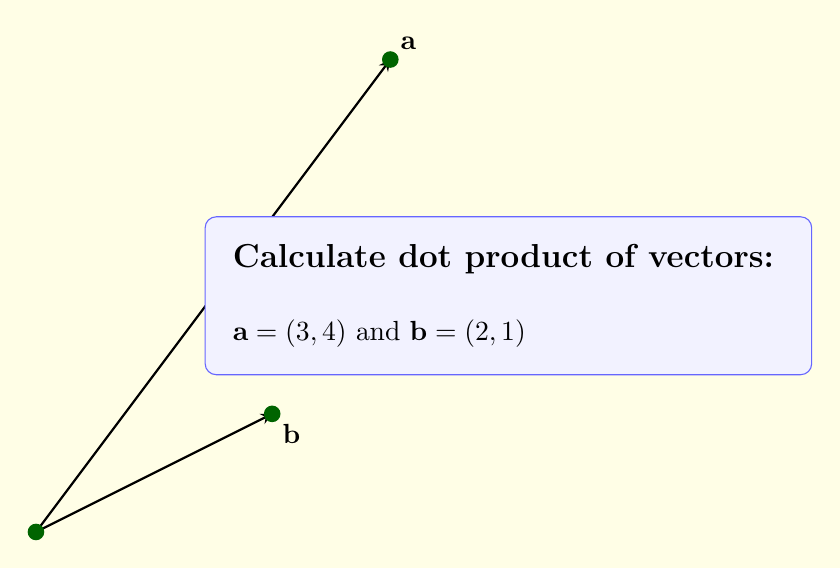Could you help me with this problem? To calculate dot product of vectors $\mathbf{a}$ and $\mathbf{b}$:

1) Dot product formula: $\mathbf{a} \cdot \mathbf{b} = a_1b_1 + a_2b_2$

2) Put values:
   $\mathbf{a} = (3,4)$, so $a_1 = 3$, $a_2 = 4$
   $\mathbf{b} = (2,1)$, so $b_1 = 2$, $b_2 = 1$

3) Calculate:
   $\mathbf{a} \cdot \mathbf{b} = (3)(2) + (4)(1)$
   $= 6 + 4$
   $= 10$
Answer: $10$ 